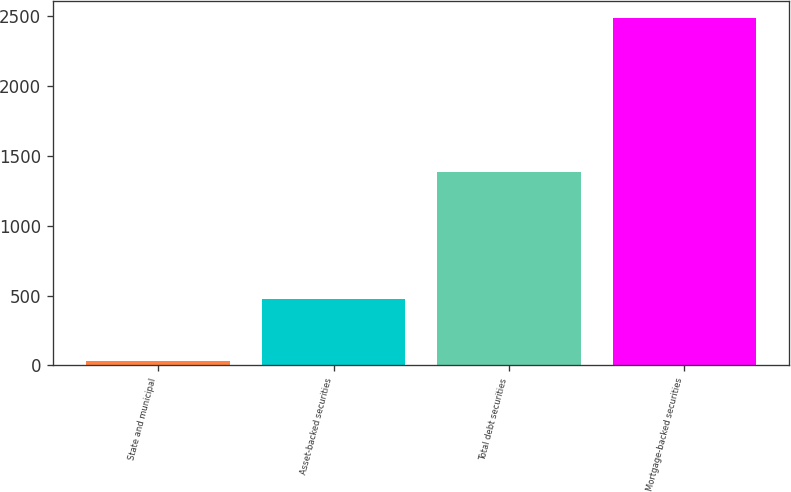Convert chart. <chart><loc_0><loc_0><loc_500><loc_500><bar_chart><fcel>State and municipal<fcel>Asset-backed securities<fcel>Total debt securities<fcel>Mortgage-backed securities<nl><fcel>34<fcel>478<fcel>1384<fcel>2484<nl></chart> 